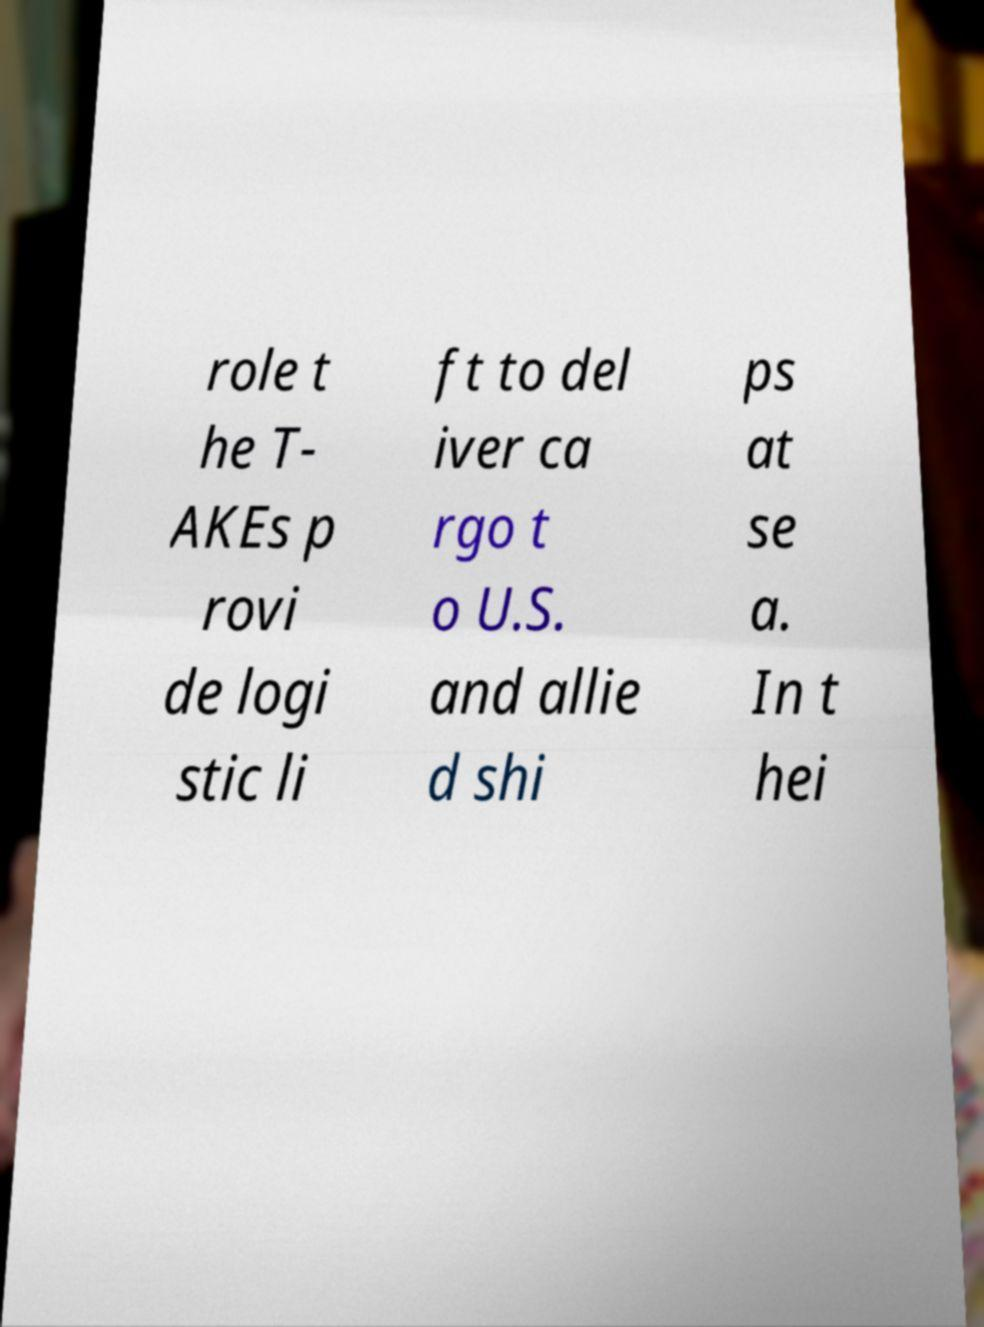For documentation purposes, I need the text within this image transcribed. Could you provide that? role t he T- AKEs p rovi de logi stic li ft to del iver ca rgo t o U.S. and allie d shi ps at se a. In t hei 